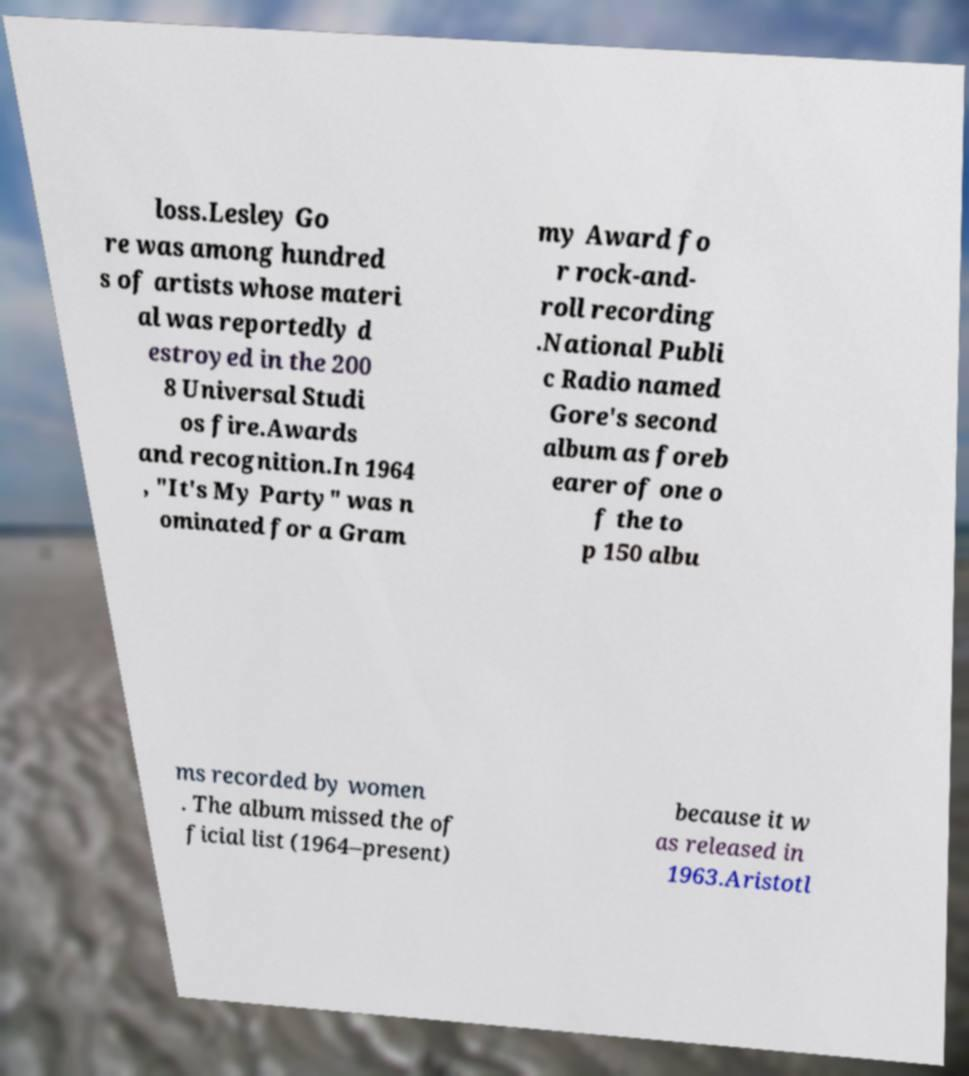Could you assist in decoding the text presented in this image and type it out clearly? loss.Lesley Go re was among hundred s of artists whose materi al was reportedly d estroyed in the 200 8 Universal Studi os fire.Awards and recognition.In 1964 , "It's My Party" was n ominated for a Gram my Award fo r rock-and- roll recording .National Publi c Radio named Gore's second album as foreb earer of one o f the to p 150 albu ms recorded by women . The album missed the of ficial list (1964–present) because it w as released in 1963.Aristotl 